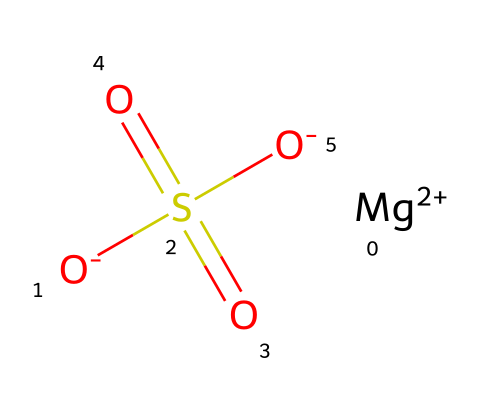How many atoms are in magnesium sulfate? The chemical structure contains 1 magnesium atom (Mg), 1 sulfur atom (S), and 4 oxygen atoms (O). Therefore, when summed up, there are a total of 6 atoms in magnesium sulfate.
Answer: 6 What is the charge of the magnesium ion in this compound? In the chemical structure, magnesium is represented as [Mg+2], indicating it has a +2 charge.
Answer: +2 How many oxygen atoms are present in magnesium sulfate? The structure shows four oxygen atoms depicted by the four instances of the letter "O." Therefore, the total number of oxygen atoms is 4.
Answer: 4 What type of compound is magnesium sulfate classified as? Magnesium sulfate is classified as an electrolyte due to its ability to conduct electricity when dissolved in water or in molten form.
Answer: electrolyte Which element provides the sulfate functional group in this compound? The sulfate functional group is identified by the sulfur atom (S) bonding with four oxygen atoms. In the SMILES, the presence of "S(=O)(=O)" indicates the sulfate group.
Answer: sulfur How many total bonds are present in magnesium sulfate? The structure indicates there are 4 bonds between the sulfur atom and the oxygen atoms, plus 1 bond between magnesium and the sulfate group, making a total of 5 bonds overall.
Answer: 5 What role does magnesium play in muscle recovery? Magnesium is essential for muscle function and recovery, helping to regulate muscle contractions and supported by its presence in compounds like magnesium sulfate.
Answer: muscle function 